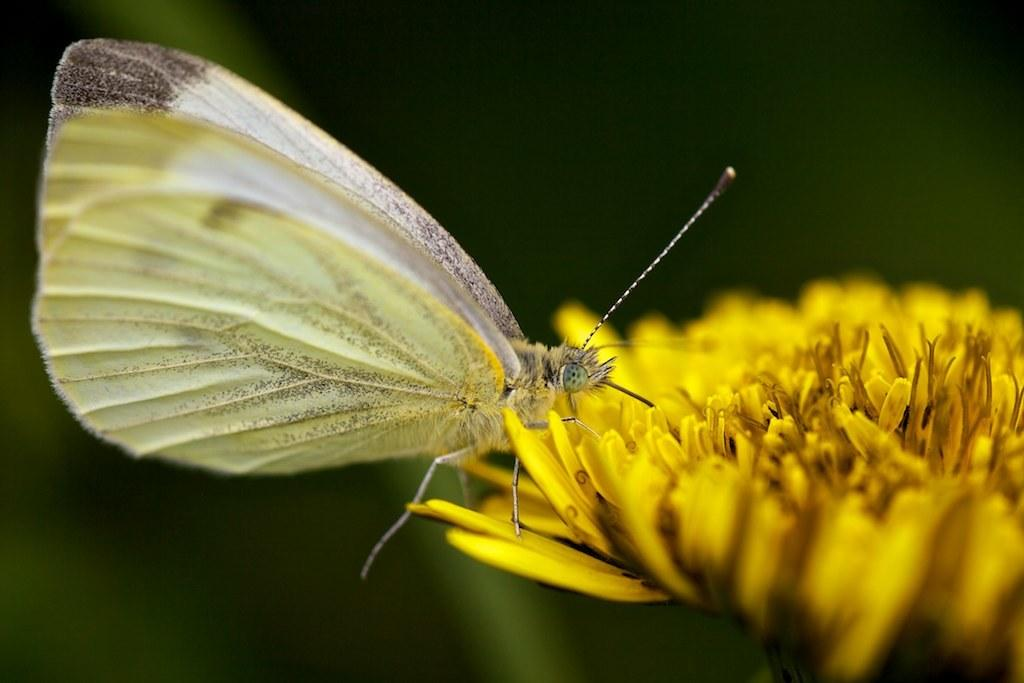What is the main subject of the image? There is a butterfly in the image. Where is the butterfly located? The butterfly is on a flower. Can you describe the background of the image? The background of the image is blurry. What type of kitty can be seen playing with a spot in the image? There is no kitty or spot present in the image; it features a butterfly on a flower with a blurry background. 